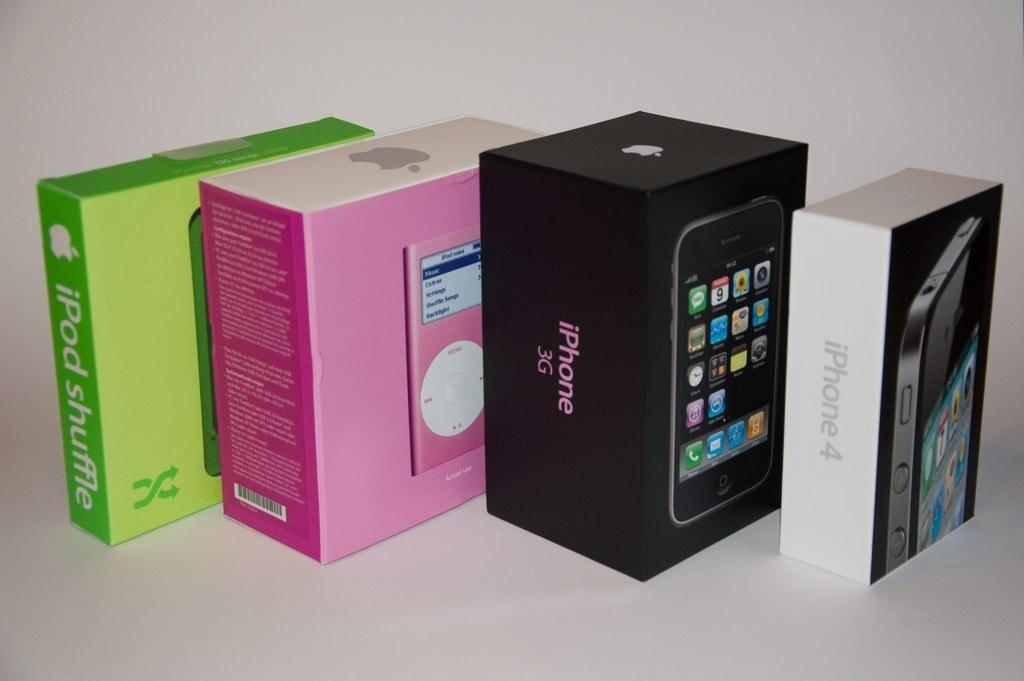<image>
Relay a brief, clear account of the picture shown. Various boxes from iPods and iPhones lined up in a row. 